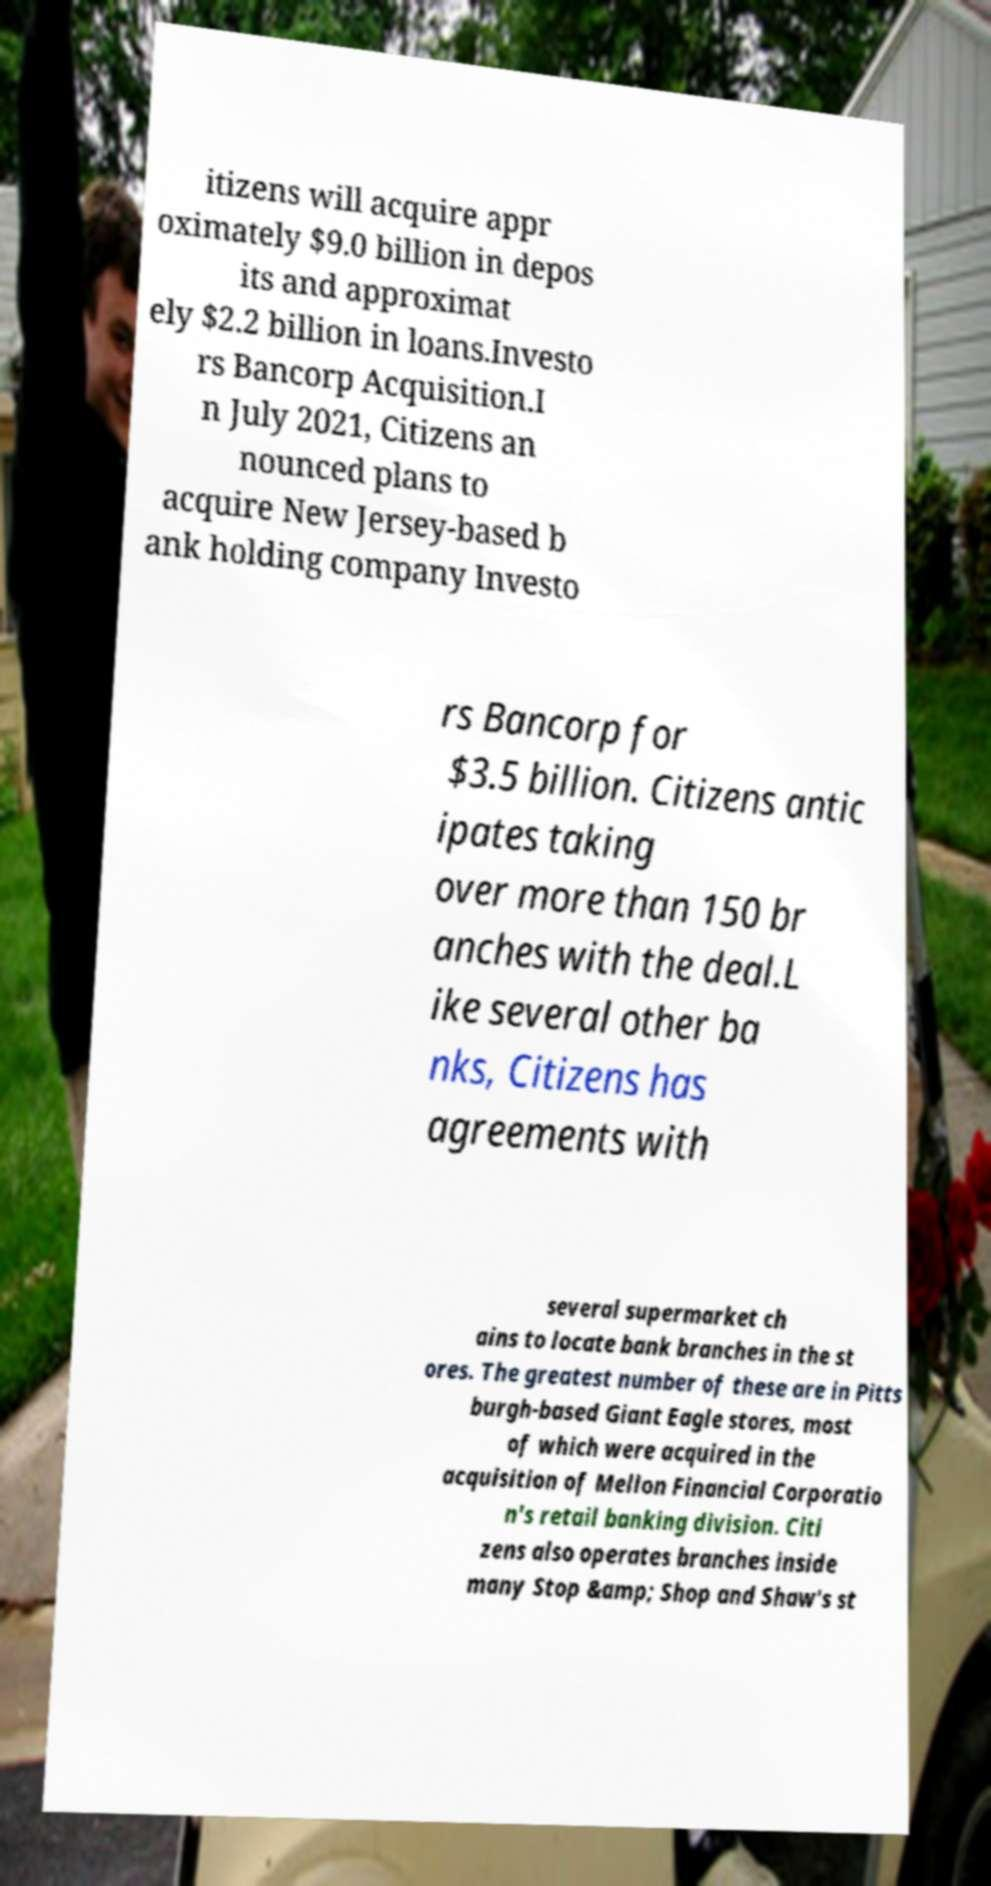I need the written content from this picture converted into text. Can you do that? itizens will acquire appr oximately $9.0 billion in depos its and approximat ely $2.2 billion in loans.Investo rs Bancorp Acquisition.I n July 2021, Citizens an nounced plans to acquire New Jersey-based b ank holding company Investo rs Bancorp for $3.5 billion. Citizens antic ipates taking over more than 150 br anches with the deal.L ike several other ba nks, Citizens has agreements with several supermarket ch ains to locate bank branches in the st ores. The greatest number of these are in Pitts burgh-based Giant Eagle stores, most of which were acquired in the acquisition of Mellon Financial Corporatio n's retail banking division. Citi zens also operates branches inside many Stop &amp; Shop and Shaw's st 